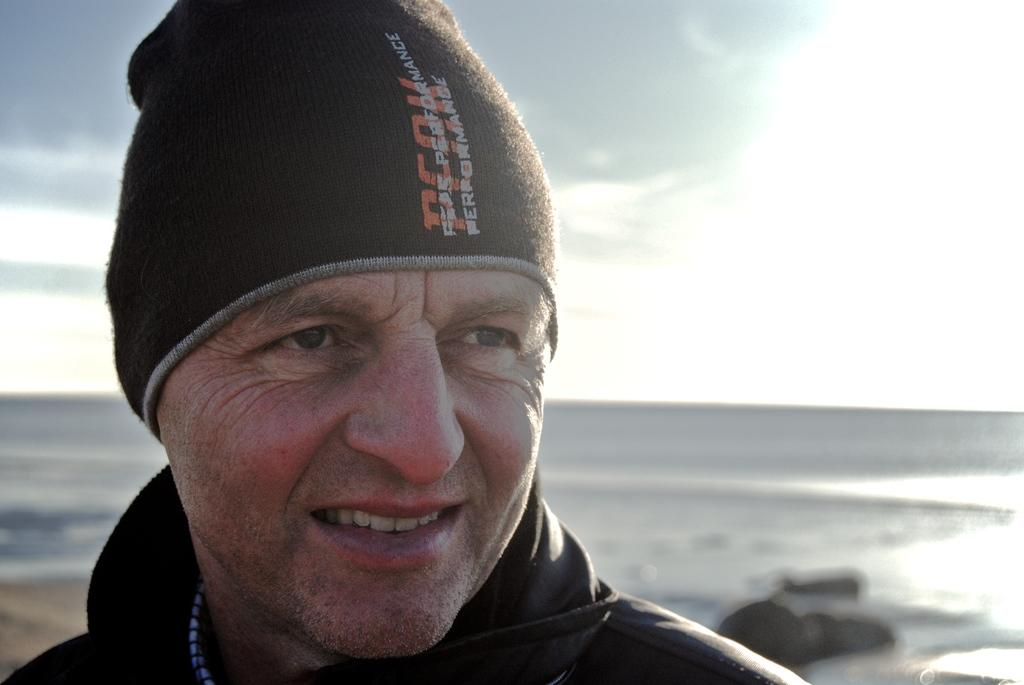Who or what is in the foreground of the image? There is a person in the foreground of the image. What is the person wearing on their head? The person is wearing a cap. What can be seen in the background of the image? Water and the sky are visible in the background of the image. What type of treatment is the person receiving in the image? There is no indication in the image that the person is receiving any treatment. What game is the person playing in the image? There is no game visible in the image. 